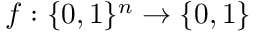Convert formula to latex. <formula><loc_0><loc_0><loc_500><loc_500>f \colon \{ 0 , 1 \} ^ { n } \rightarrow \{ 0 , 1 \}</formula> 